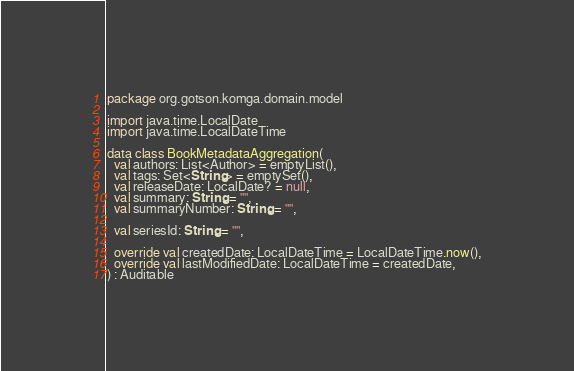<code> <loc_0><loc_0><loc_500><loc_500><_Kotlin_>package org.gotson.komga.domain.model

import java.time.LocalDate
import java.time.LocalDateTime

data class BookMetadataAggregation(
  val authors: List<Author> = emptyList(),
  val tags: Set<String> = emptySet(),
  val releaseDate: LocalDate? = null,
  val summary: String = "",
  val summaryNumber: String = "",

  val seriesId: String = "",

  override val createdDate: LocalDateTime = LocalDateTime.now(),
  override val lastModifiedDate: LocalDateTime = createdDate,
) : Auditable
</code> 